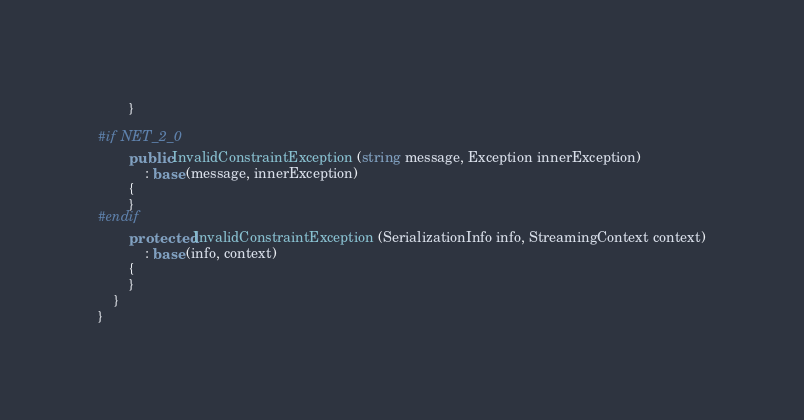Convert code to text. <code><loc_0><loc_0><loc_500><loc_500><_C#_>		}

#if NET_2_0
		public InvalidConstraintException (string message, Exception innerException)
			: base (message, innerException)
		{
		}
#endif
		protected InvalidConstraintException (SerializationInfo info, StreamingContext context)
			: base (info, context)
		{
		}
	}
}
</code> 